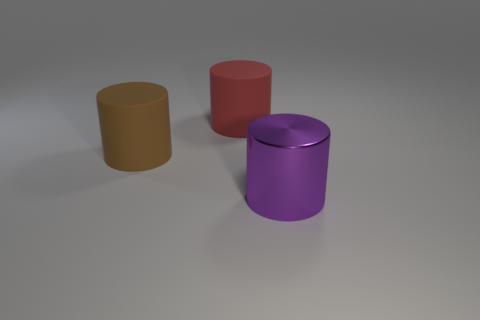Are there any other things that are the same material as the large purple object?
Your answer should be compact. No. There is a purple thing that is the same shape as the big red matte thing; what is it made of?
Provide a short and direct response. Metal. There is a big object that is in front of the red cylinder and to the right of the brown rubber thing; what is its material?
Your answer should be compact. Metal. What is the color of the cylinder that is left of the big cylinder that is behind the big rubber cylinder that is in front of the red thing?
Make the answer very short. Brown. What number of objects are purple rubber cylinders or matte cylinders?
Ensure brevity in your answer.  2. What number of objects are either gray blocks or big objects that are to the left of the large purple thing?
Provide a succinct answer. 2. Do the large purple thing and the big red cylinder have the same material?
Offer a terse response. No. How many other things are made of the same material as the big red thing?
Ensure brevity in your answer.  1. Is the number of matte things greater than the number of objects?
Give a very brief answer. No. Are there fewer large red objects than large cyan matte balls?
Provide a succinct answer. No. 